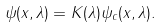Convert formula to latex. <formula><loc_0><loc_0><loc_500><loc_500>\psi ( x , \lambda ) = K ( \lambda ) \psi _ { c } ( x , \lambda ) .</formula> 